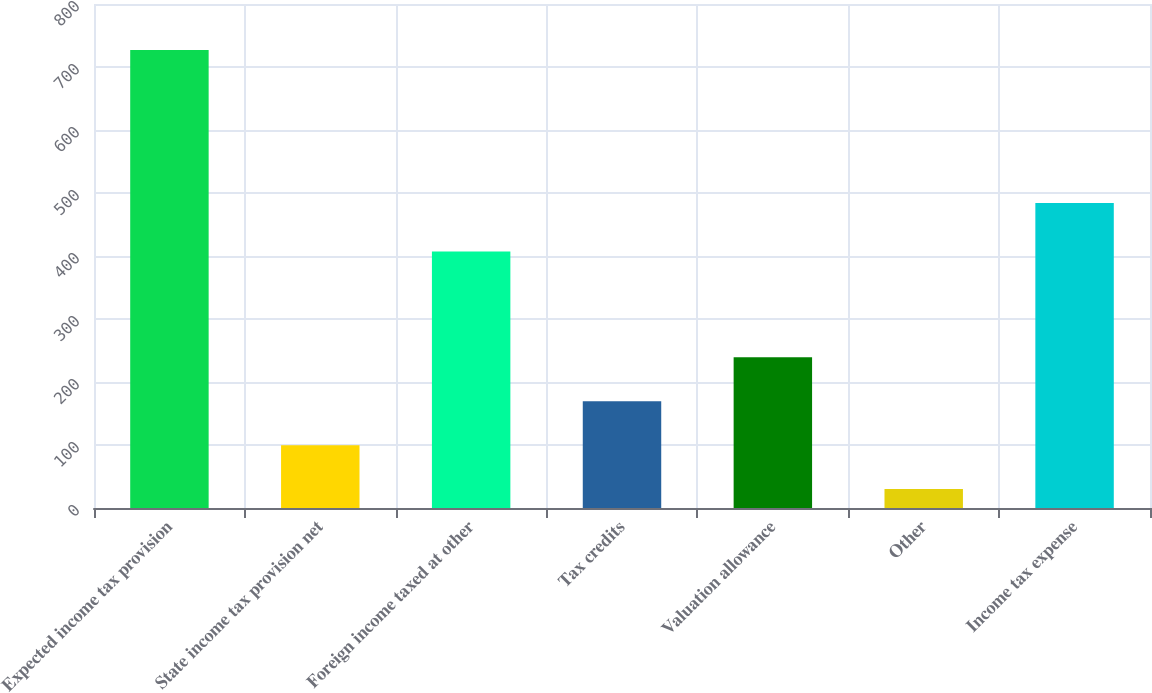<chart> <loc_0><loc_0><loc_500><loc_500><bar_chart><fcel>Expected income tax provision<fcel>State income tax provision net<fcel>Foreign income taxed at other<fcel>Tax credits<fcel>Valuation allowance<fcel>Other<fcel>Income tax expense<nl><fcel>727<fcel>99.7<fcel>407<fcel>169.4<fcel>239.1<fcel>30<fcel>484<nl></chart> 